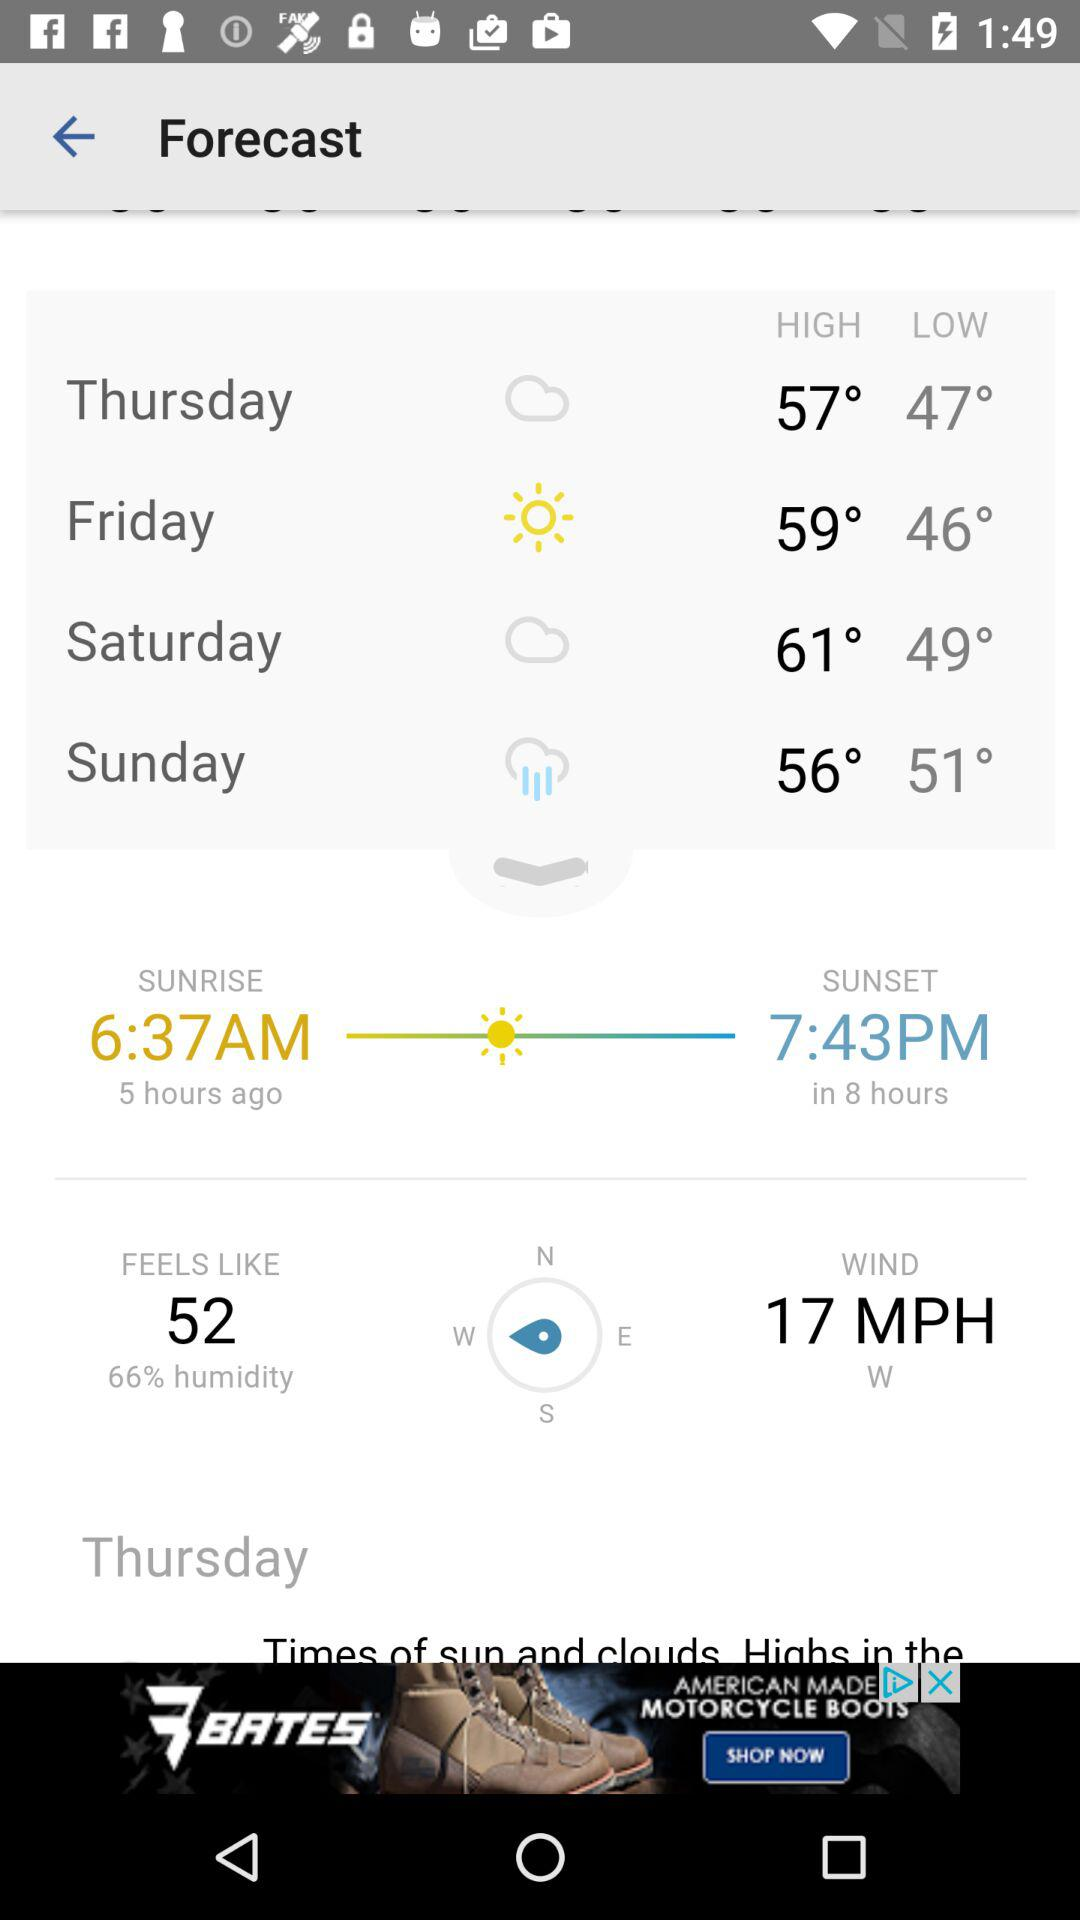Will it rain tomorrow?
When the provided information is insufficient, respond with <no answer>. <no answer> 